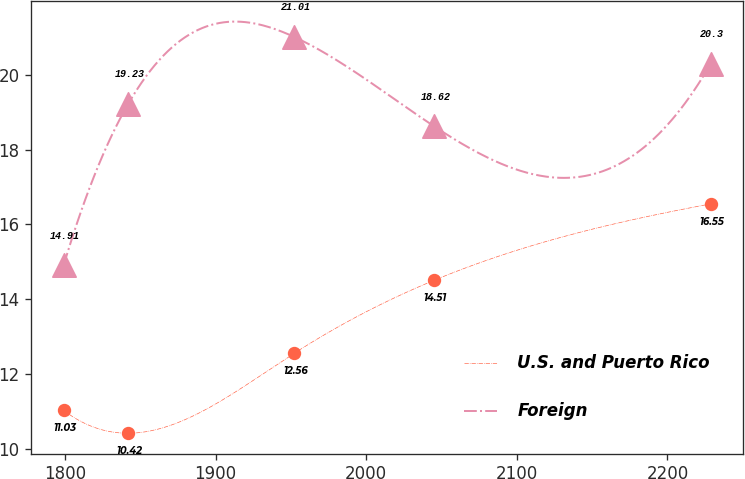Convert chart. <chart><loc_0><loc_0><loc_500><loc_500><line_chart><ecel><fcel>U.S. and Puerto Rico<fcel>Foreign<nl><fcel>1799.05<fcel>11.03<fcel>14.91<nl><fcel>1842.03<fcel>10.42<fcel>19.23<nl><fcel>1952.32<fcel>12.56<fcel>21.01<nl><fcel>2045.22<fcel>14.51<fcel>18.62<nl><fcel>2228.85<fcel>16.55<fcel>20.3<nl></chart> 